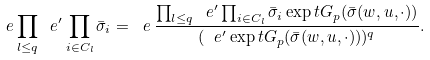<formula> <loc_0><loc_0><loc_500><loc_500>\ e \prod _ { l \leq q } \ e ^ { \prime } \prod _ { i \in C _ { l } } \bar { \sigma } _ { i } = \ e \, \frac { \prod _ { l \leq q } \ e ^ { \prime } \prod _ { i \in C _ { l } } \bar { \sigma } _ { i } \exp t G _ { p } ( \bar { \sigma } ( w , u , \cdot ) ) } { ( \ e ^ { \prime } \exp t G _ { p } ( \bar { \sigma } ( w , u , \cdot ) ) ) ^ { q } } .</formula> 